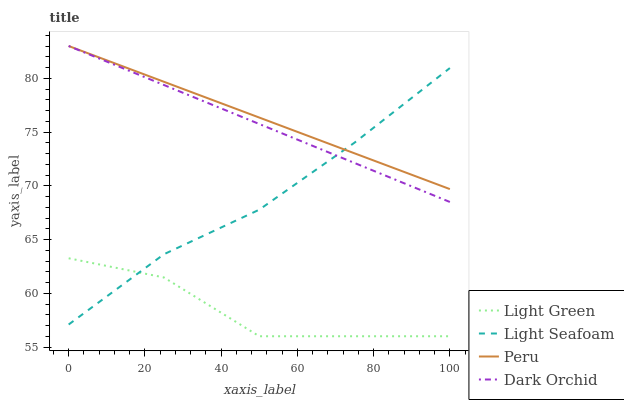Does Light Green have the minimum area under the curve?
Answer yes or no. Yes. Does Peru have the maximum area under the curve?
Answer yes or no. Yes. Does Light Seafoam have the minimum area under the curve?
Answer yes or no. No. Does Light Seafoam have the maximum area under the curve?
Answer yes or no. No. Is Dark Orchid the smoothest?
Answer yes or no. Yes. Is Light Green the roughest?
Answer yes or no. Yes. Is Light Seafoam the smoothest?
Answer yes or no. No. Is Light Seafoam the roughest?
Answer yes or no. No. Does Light Green have the lowest value?
Answer yes or no. Yes. Does Light Seafoam have the lowest value?
Answer yes or no. No. Does Peru have the highest value?
Answer yes or no. Yes. Does Light Seafoam have the highest value?
Answer yes or no. No. Is Light Green less than Peru?
Answer yes or no. Yes. Is Dark Orchid greater than Light Green?
Answer yes or no. Yes. Does Dark Orchid intersect Peru?
Answer yes or no. Yes. Is Dark Orchid less than Peru?
Answer yes or no. No. Is Dark Orchid greater than Peru?
Answer yes or no. No. Does Light Green intersect Peru?
Answer yes or no. No. 